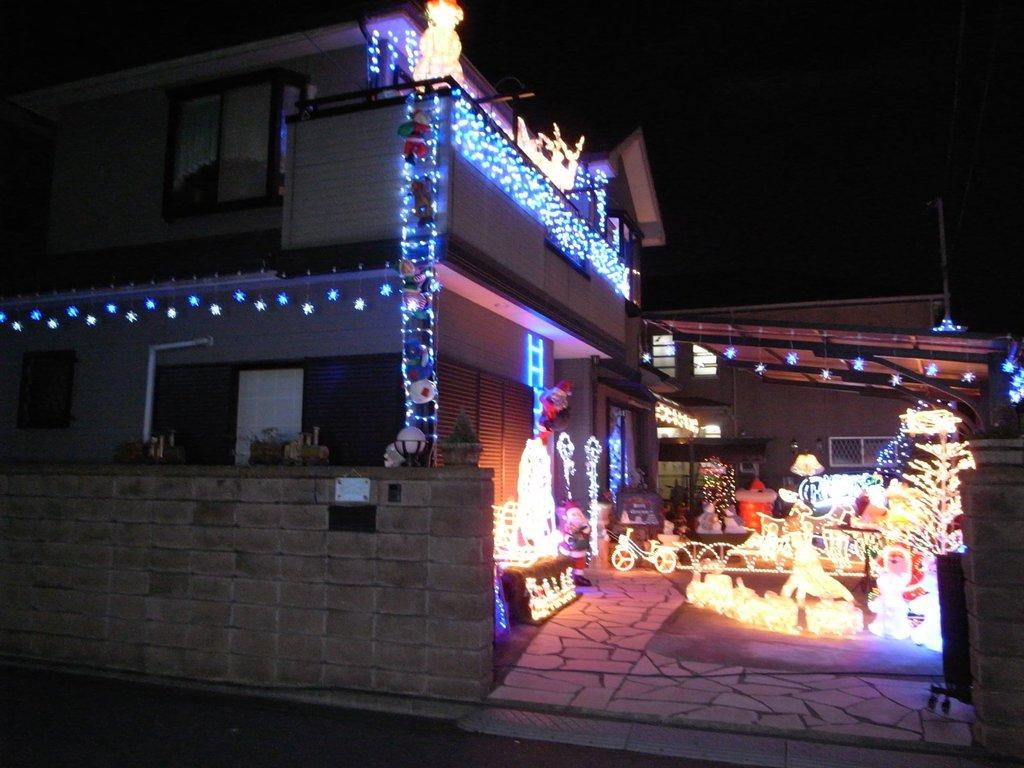How is the house decorated in the image? The house is decorated with lights. Are there any other objects near the house that are also decorated with lights? Yes, there are objects near the house that are also decorated with lights. What type of lunch is being served on the slope near the house? There is no mention of a slope or lunch in the image; the focus is on the house and objects decorated with lights. 